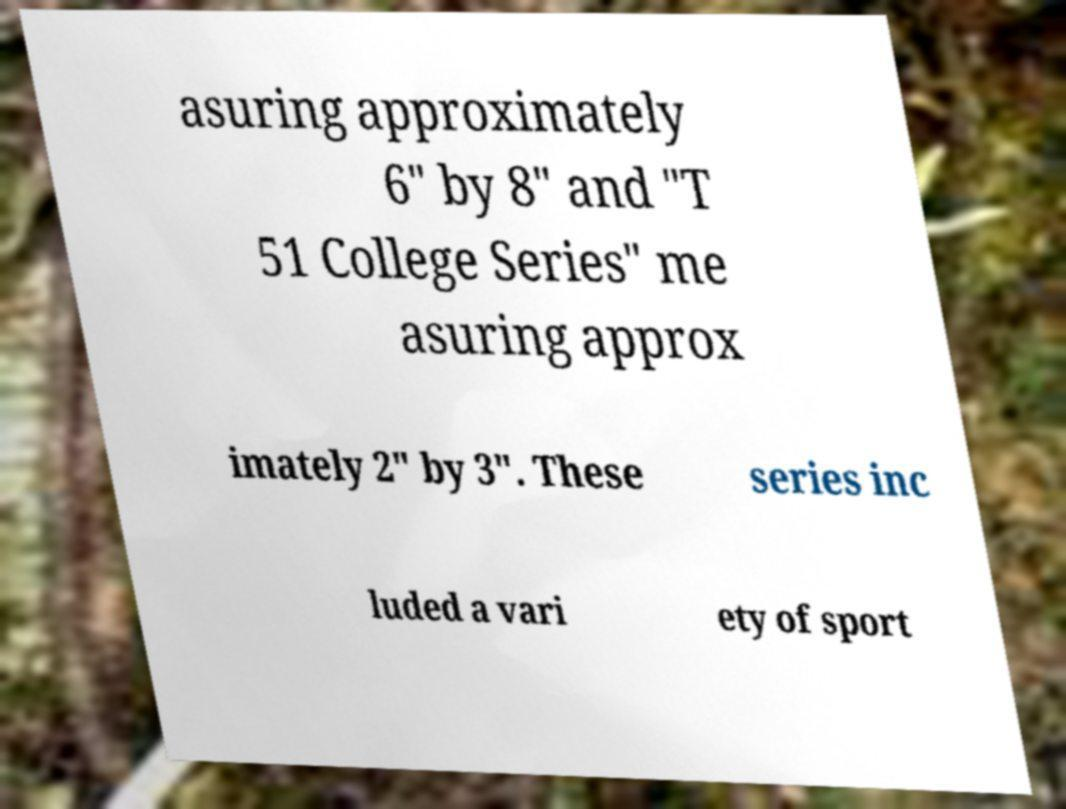Please read and relay the text visible in this image. What does it say? asuring approximately 6" by 8" and "T 51 College Series" me asuring approx imately 2" by 3". These series inc luded a vari ety of sport 